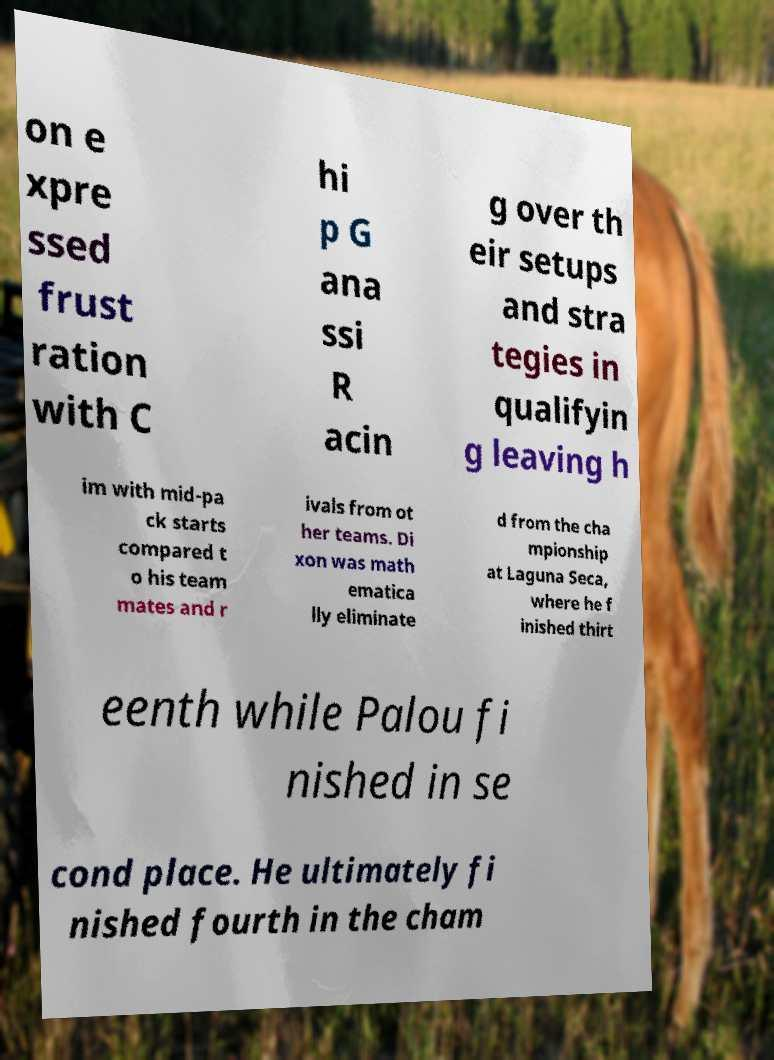Please identify and transcribe the text found in this image. on e xpre ssed frust ration with C hi p G ana ssi R acin g over th eir setups and stra tegies in qualifyin g leaving h im with mid-pa ck starts compared t o his team mates and r ivals from ot her teams. Di xon was math ematica lly eliminate d from the cha mpionship at Laguna Seca, where he f inished thirt eenth while Palou fi nished in se cond place. He ultimately fi nished fourth in the cham 